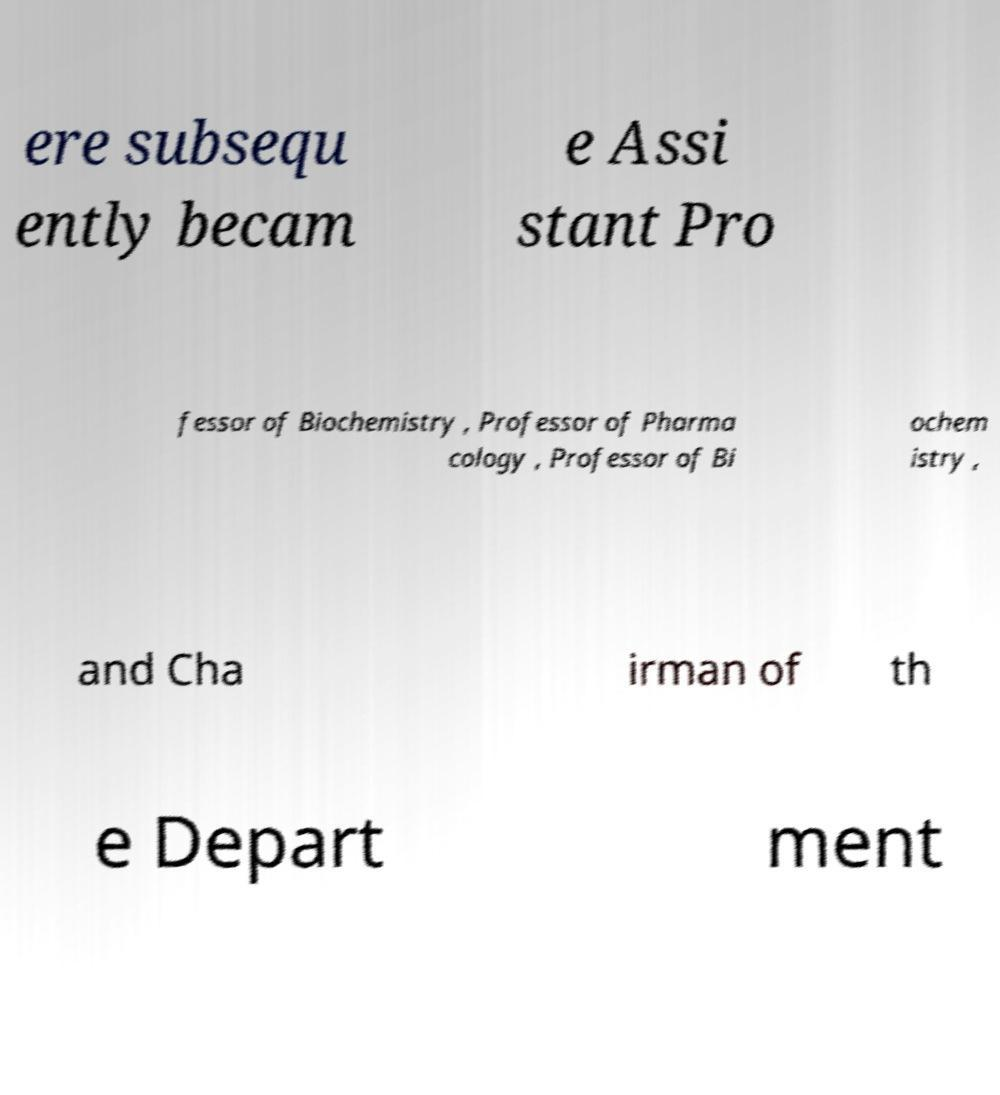For documentation purposes, I need the text within this image transcribed. Could you provide that? ere subsequ ently becam e Assi stant Pro fessor of Biochemistry , Professor of Pharma cology , Professor of Bi ochem istry , and Cha irman of th e Depart ment 